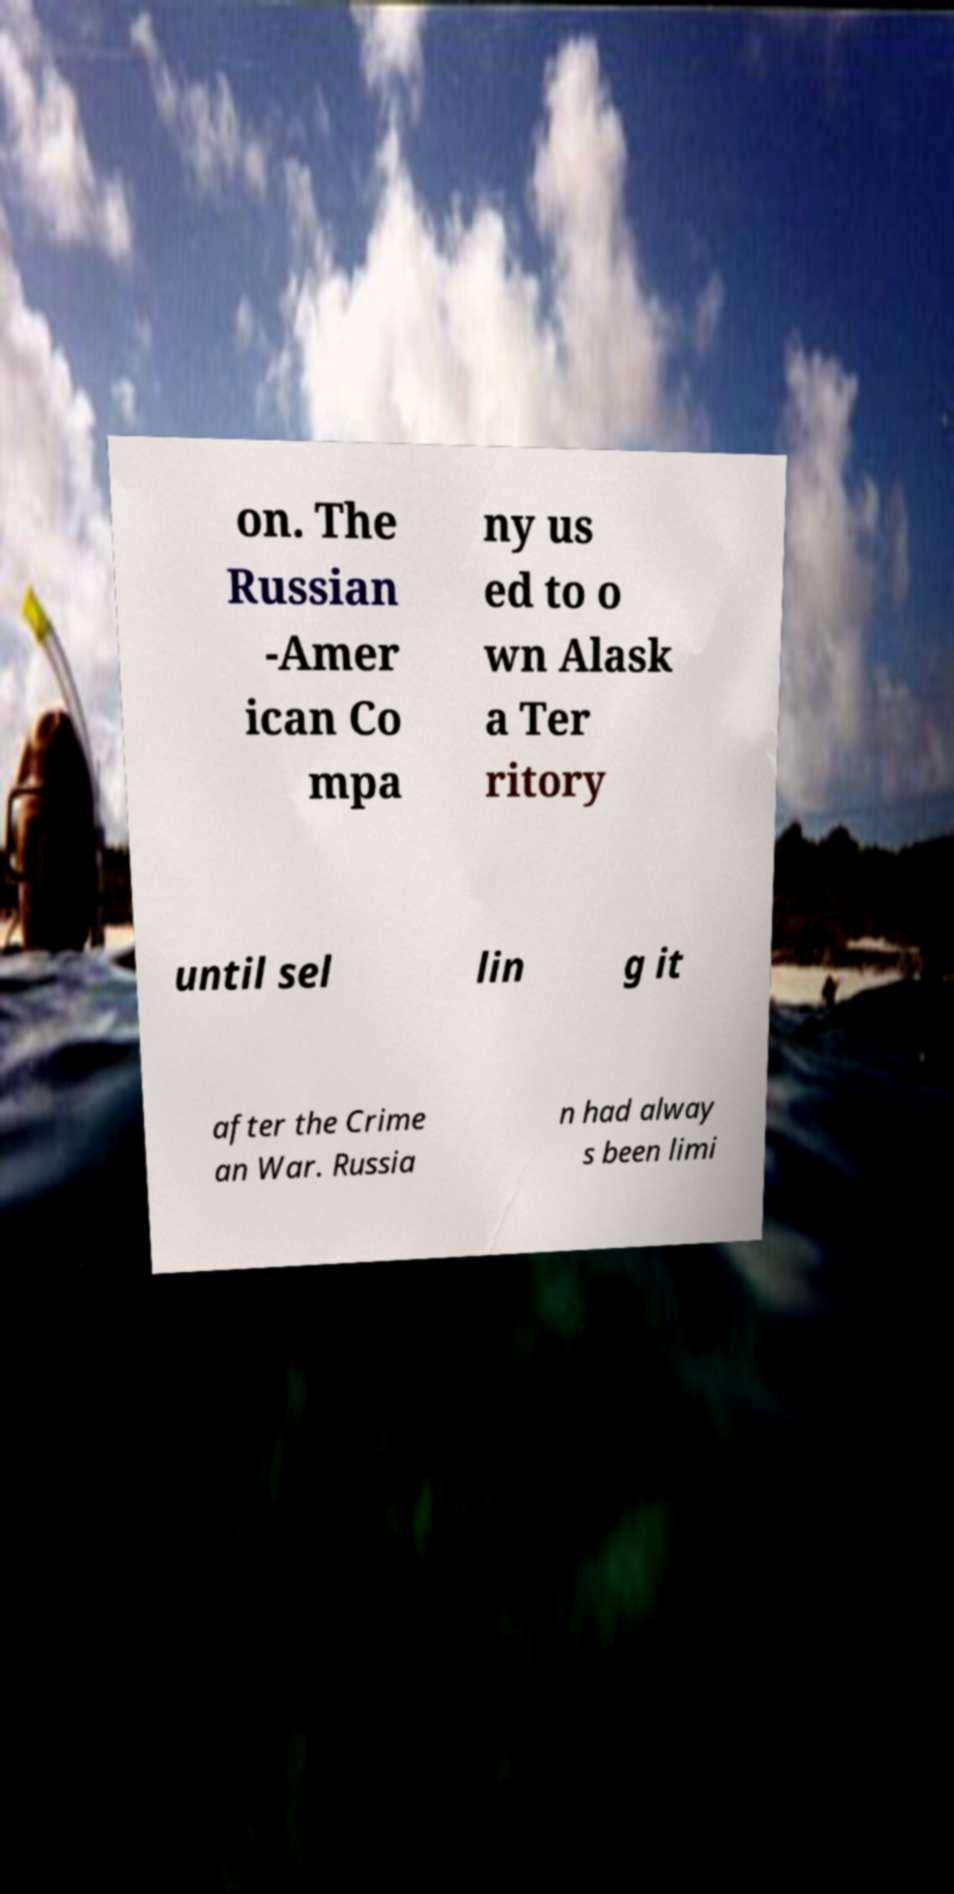Can you read and provide the text displayed in the image?This photo seems to have some interesting text. Can you extract and type it out for me? on. The Russian -Amer ican Co mpa ny us ed to o wn Alask a Ter ritory until sel lin g it after the Crime an War. Russia n had alway s been limi 